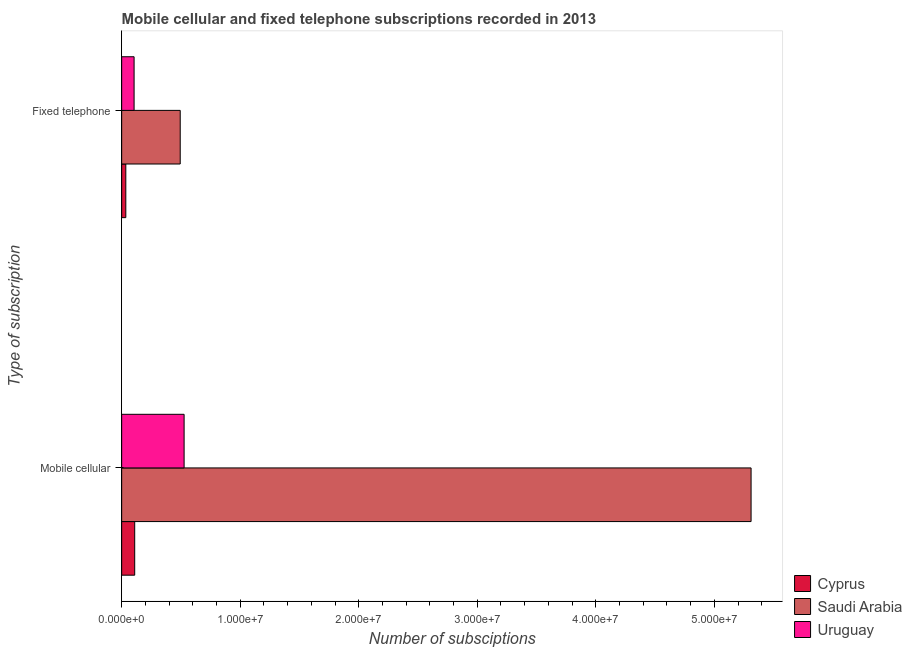How many different coloured bars are there?
Offer a terse response. 3. Are the number of bars per tick equal to the number of legend labels?
Your response must be concise. Yes. Are the number of bars on each tick of the Y-axis equal?
Offer a terse response. Yes. How many bars are there on the 1st tick from the top?
Give a very brief answer. 3. What is the label of the 1st group of bars from the top?
Make the answer very short. Fixed telephone. What is the number of fixed telephone subscriptions in Uruguay?
Your answer should be compact. 1.05e+06. Across all countries, what is the maximum number of mobile cellular subscriptions?
Keep it short and to the point. 5.31e+07. Across all countries, what is the minimum number of mobile cellular subscriptions?
Ensure brevity in your answer.  1.10e+06. In which country was the number of fixed telephone subscriptions maximum?
Offer a terse response. Saudi Arabia. In which country was the number of mobile cellular subscriptions minimum?
Provide a succinct answer. Cyprus. What is the total number of fixed telephone subscriptions in the graph?
Your answer should be compact. 6.34e+06. What is the difference between the number of fixed telephone subscriptions in Saudi Arabia and that in Uruguay?
Ensure brevity in your answer.  3.89e+06. What is the difference between the number of fixed telephone subscriptions in Cyprus and the number of mobile cellular subscriptions in Saudi Arabia?
Offer a terse response. -5.28e+07. What is the average number of mobile cellular subscriptions per country?
Your response must be concise. 1.98e+07. What is the difference between the number of fixed telephone subscriptions and number of mobile cellular subscriptions in Saudi Arabia?
Make the answer very short. -4.82e+07. In how many countries, is the number of fixed telephone subscriptions greater than 40000000 ?
Offer a very short reply. 0. What is the ratio of the number of fixed telephone subscriptions in Cyprus to that in Saudi Arabia?
Offer a terse response. 0.07. What does the 3rd bar from the top in Mobile cellular represents?
Provide a short and direct response. Cyprus. What does the 2nd bar from the bottom in Fixed telephone represents?
Keep it short and to the point. Saudi Arabia. How many bars are there?
Offer a terse response. 6. Are the values on the major ticks of X-axis written in scientific E-notation?
Keep it short and to the point. Yes. Does the graph contain grids?
Offer a terse response. No. Where does the legend appear in the graph?
Provide a succinct answer. Bottom right. What is the title of the graph?
Offer a terse response. Mobile cellular and fixed telephone subscriptions recorded in 2013. Does "Micronesia" appear as one of the legend labels in the graph?
Your response must be concise. No. What is the label or title of the X-axis?
Your answer should be compact. Number of subsciptions. What is the label or title of the Y-axis?
Your answer should be compact. Type of subscription. What is the Number of subsciptions of Cyprus in Mobile cellular?
Offer a terse response. 1.10e+06. What is the Number of subsciptions of Saudi Arabia in Mobile cellular?
Keep it short and to the point. 5.31e+07. What is the Number of subsciptions in Uruguay in Mobile cellular?
Provide a succinct answer. 5.27e+06. What is the Number of subsciptions of Cyprus in Fixed telephone?
Make the answer very short. 3.49e+05. What is the Number of subsciptions of Saudi Arabia in Fixed telephone?
Provide a short and direct response. 4.94e+06. What is the Number of subsciptions of Uruguay in Fixed telephone?
Your answer should be very brief. 1.05e+06. Across all Type of subscription, what is the maximum Number of subsciptions of Cyprus?
Give a very brief answer. 1.10e+06. Across all Type of subscription, what is the maximum Number of subsciptions in Saudi Arabia?
Offer a terse response. 5.31e+07. Across all Type of subscription, what is the maximum Number of subsciptions in Uruguay?
Offer a very short reply. 5.27e+06. Across all Type of subscription, what is the minimum Number of subsciptions of Cyprus?
Give a very brief answer. 3.49e+05. Across all Type of subscription, what is the minimum Number of subsciptions in Saudi Arabia?
Keep it short and to the point. 4.94e+06. Across all Type of subscription, what is the minimum Number of subsciptions in Uruguay?
Keep it short and to the point. 1.05e+06. What is the total Number of subsciptions of Cyprus in the graph?
Keep it short and to the point. 1.45e+06. What is the total Number of subsciptions of Saudi Arabia in the graph?
Provide a short and direct response. 5.80e+07. What is the total Number of subsciptions of Uruguay in the graph?
Your answer should be very brief. 6.32e+06. What is the difference between the Number of subsciptions in Cyprus in Mobile cellular and that in Fixed telephone?
Offer a terse response. 7.51e+05. What is the difference between the Number of subsciptions in Saudi Arabia in Mobile cellular and that in Fixed telephone?
Provide a short and direct response. 4.82e+07. What is the difference between the Number of subsciptions in Uruguay in Mobile cellular and that in Fixed telephone?
Provide a short and direct response. 4.22e+06. What is the difference between the Number of subsciptions in Cyprus in Mobile cellular and the Number of subsciptions in Saudi Arabia in Fixed telephone?
Offer a terse response. -3.84e+06. What is the difference between the Number of subsciptions of Cyprus in Mobile cellular and the Number of subsciptions of Uruguay in Fixed telephone?
Provide a short and direct response. 5.12e+04. What is the difference between the Number of subsciptions in Saudi Arabia in Mobile cellular and the Number of subsciptions in Uruguay in Fixed telephone?
Your answer should be very brief. 5.21e+07. What is the average Number of subsciptions of Cyprus per Type of subscription?
Make the answer very short. 7.24e+05. What is the average Number of subsciptions in Saudi Arabia per Type of subscription?
Ensure brevity in your answer.  2.90e+07. What is the average Number of subsciptions of Uruguay per Type of subscription?
Your answer should be very brief. 3.16e+06. What is the difference between the Number of subsciptions in Cyprus and Number of subsciptions in Saudi Arabia in Mobile cellular?
Your answer should be very brief. -5.20e+07. What is the difference between the Number of subsciptions in Cyprus and Number of subsciptions in Uruguay in Mobile cellular?
Ensure brevity in your answer.  -4.17e+06. What is the difference between the Number of subsciptions in Saudi Arabia and Number of subsciptions in Uruguay in Mobile cellular?
Make the answer very short. 4.78e+07. What is the difference between the Number of subsciptions of Cyprus and Number of subsciptions of Saudi Arabia in Fixed telephone?
Ensure brevity in your answer.  -4.59e+06. What is the difference between the Number of subsciptions of Cyprus and Number of subsciptions of Uruguay in Fixed telephone?
Make the answer very short. -6.99e+05. What is the difference between the Number of subsciptions of Saudi Arabia and Number of subsciptions of Uruguay in Fixed telephone?
Make the answer very short. 3.89e+06. What is the ratio of the Number of subsciptions of Cyprus in Mobile cellular to that in Fixed telephone?
Provide a succinct answer. 3.15. What is the ratio of the Number of subsciptions in Saudi Arabia in Mobile cellular to that in Fixed telephone?
Offer a very short reply. 10.75. What is the ratio of the Number of subsciptions of Uruguay in Mobile cellular to that in Fixed telephone?
Provide a succinct answer. 5.02. What is the difference between the highest and the second highest Number of subsciptions of Cyprus?
Provide a short and direct response. 7.51e+05. What is the difference between the highest and the second highest Number of subsciptions in Saudi Arabia?
Provide a short and direct response. 4.82e+07. What is the difference between the highest and the second highest Number of subsciptions in Uruguay?
Provide a succinct answer. 4.22e+06. What is the difference between the highest and the lowest Number of subsciptions of Cyprus?
Provide a succinct answer. 7.51e+05. What is the difference between the highest and the lowest Number of subsciptions in Saudi Arabia?
Provide a succinct answer. 4.82e+07. What is the difference between the highest and the lowest Number of subsciptions of Uruguay?
Your answer should be compact. 4.22e+06. 